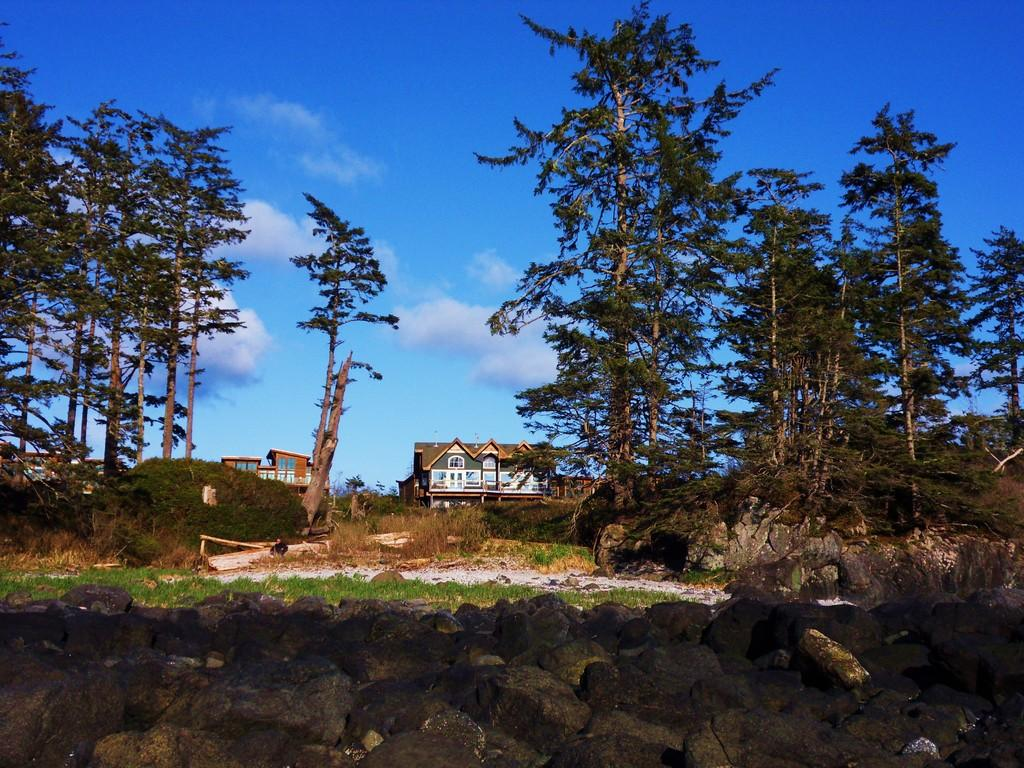What type of vegetation can be seen in the image? There are trees in the image. What other natural elements are present in the image? There are rocks and grass in the image. What type of structures can be seen in the image? There are houses in the image. What is visible in the background of the image? The sky is visible in the background of the image. What can be observed in the sky? Clouds are present in the sky. Can you tell me the credit score of the person who owns the house in the image? There is no information about the credit score or the owner of the house in the image. What type of shade is provided by the trees in the image? The image does not show the trees providing shade; it only shows their presence. 